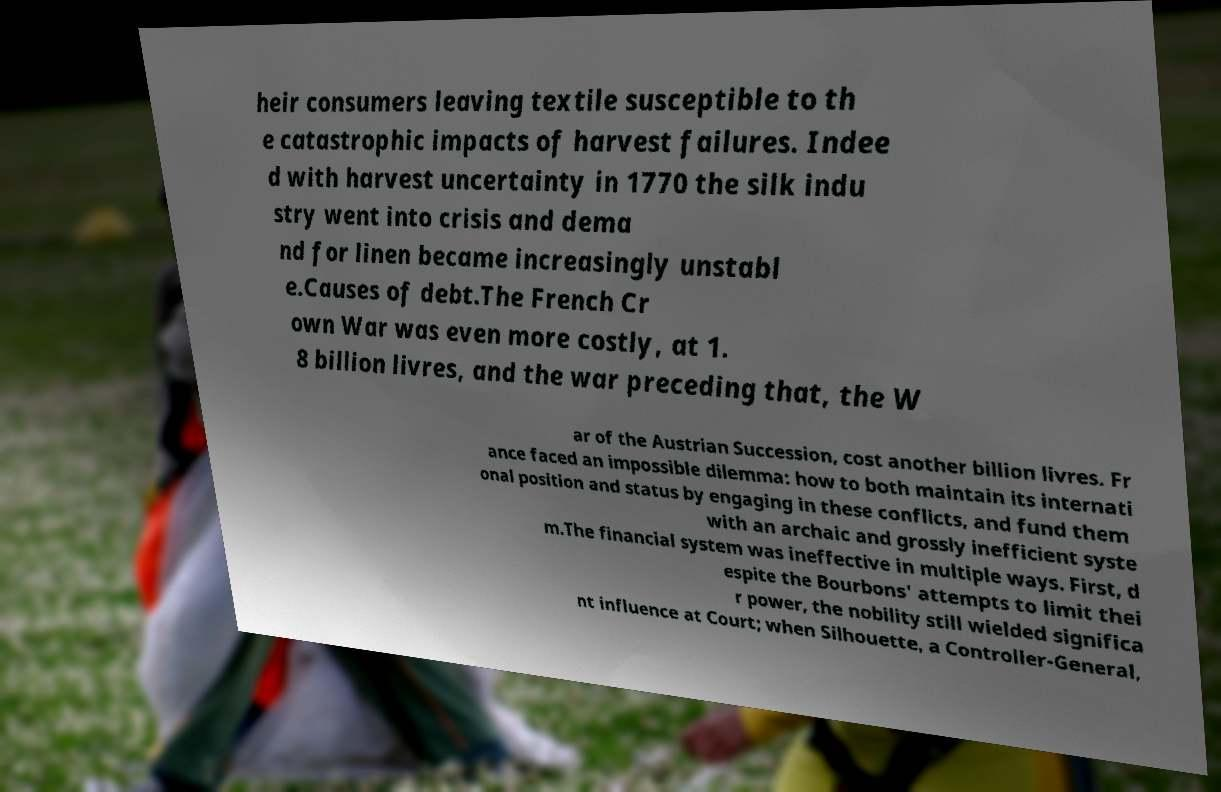There's text embedded in this image that I need extracted. Can you transcribe it verbatim? heir consumers leaving textile susceptible to th e catastrophic impacts of harvest failures. Indee d with harvest uncertainty in 1770 the silk indu stry went into crisis and dema nd for linen became increasingly unstabl e.Causes of debt.The French Cr own War was even more costly, at 1. 8 billion livres, and the war preceding that, the W ar of the Austrian Succession, cost another billion livres. Fr ance faced an impossible dilemma: how to both maintain its internati onal position and status by engaging in these conflicts, and fund them with an archaic and grossly inefficient syste m.The financial system was ineffective in multiple ways. First, d espite the Bourbons' attempts to limit thei r power, the nobility still wielded significa nt influence at Court; when Silhouette, a Controller-General, 